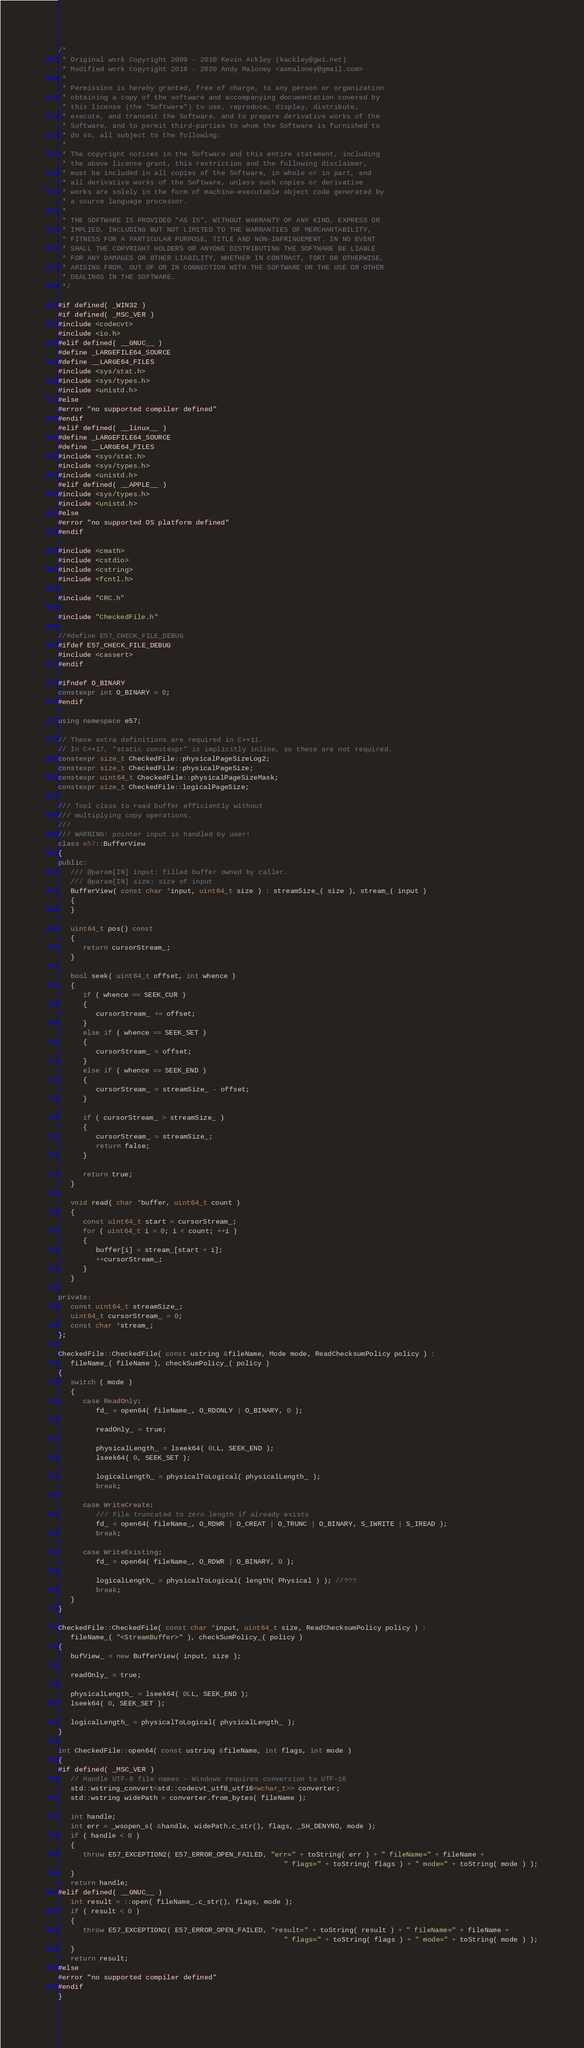Convert code to text. <code><loc_0><loc_0><loc_500><loc_500><_C++_>/*
 * Original work Copyright 2009 - 2010 Kevin Ackley (kackley@gwi.net)
 * Modified work Copyright 2018 - 2020 Andy Maloney <asmaloney@gmail.com>
 *
 * Permission is hereby granted, free of charge, to any person or organization
 * obtaining a copy of the software and accompanying documentation covered by
 * this license (the "Software") to use, reproduce, display, distribute,
 * execute, and transmit the Software, and to prepare derivative works of the
 * Software, and to permit third-parties to whom the Software is furnished to
 * do so, all subject to the following:
 *
 * The copyright notices in the Software and this entire statement, including
 * the above license grant, this restriction and the following disclaimer,
 * must be included in all copies of the Software, in whole or in part, and
 * all derivative works of the Software, unless such copies or derivative
 * works are solely in the form of machine-executable object code generated by
 * a source language processor.
 *
 * THE SOFTWARE IS PROVIDED "AS IS", WITHOUT WARRANTY OF ANY KIND, EXPRESS OR
 * IMPLIED, INCLUDING BUT NOT LIMITED TO THE WARRANTIES OF MERCHANTABILITY,
 * FITNESS FOR A PARTICULAR PURPOSE, TITLE AND NON-INFRINGEMENT. IN NO EVENT
 * SHALL THE COPYRIGHT HOLDERS OR ANYONE DISTRIBUTING THE SOFTWARE BE LIABLE
 * FOR ANY DAMAGES OR OTHER LIABILITY, WHETHER IN CONTRACT, TORT OR OTHERWISE,
 * ARISING FROM, OUT OF OR IN CONNECTION WITH THE SOFTWARE OR THE USE OR OTHER
 * DEALINGS IN THE SOFTWARE.
 */

#if defined( _WIN32 )
#if defined( _MSC_VER )
#include <codecvt>
#include <io.h>
#elif defined( __GNUC__ )
#define _LARGEFILE64_SOURCE
#define __LARGE64_FILES
#include <sys/stat.h>
#include <sys/types.h>
#include <unistd.h>
#else
#error "no supported compiler defined"
#endif
#elif defined( __linux__ )
#define _LARGEFILE64_SOURCE
#define __LARGE64_FILES
#include <sys/stat.h>
#include <sys/types.h>
#include <unistd.h>
#elif defined( __APPLE__ )
#include <sys/types.h>
#include <unistd.h>
#else
#error "no supported OS platform defined"
#endif

#include <cmath>
#include <cstdio>
#include <cstring>
#include <fcntl.h>

#include "CRC.h"

#include "CheckedFile.h"

//#define E57_CHECK_FILE_DEBUG
#ifdef E57_CHECK_FILE_DEBUG
#include <cassert>
#endif

#ifndef O_BINARY
constexpr int O_BINARY = 0;
#endif

using namespace e57;

// These extra definitions are required in C++11.
// In C++17, "static constexpr" is implicitly inline, so these are not required.
constexpr size_t CheckedFile::physicalPageSizeLog2;
constexpr size_t CheckedFile::physicalPageSize;
constexpr uint64_t CheckedFile::physicalPageSizeMask;
constexpr size_t CheckedFile::logicalPageSize;

/// Tool class to read buffer efficiently without
/// multiplying copy operations.
///
/// WARNING: pointer input is handled by user!
class e57::BufferView
{
public:
   /// @param[IN] input: filled buffer owned by caller.
   /// @param[IN] size: size of input
   BufferView( const char *input, uint64_t size ) : streamSize_( size ), stream_( input )
   {
   }

   uint64_t pos() const
   {
      return cursorStream_;
   }

   bool seek( uint64_t offset, int whence )
   {
      if ( whence == SEEK_CUR )
      {
         cursorStream_ += offset;
      }
      else if ( whence == SEEK_SET )
      {
         cursorStream_ = offset;
      }
      else if ( whence == SEEK_END )
      {
         cursorStream_ = streamSize_ - offset;
      }

      if ( cursorStream_ > streamSize_ )
      {
         cursorStream_ = streamSize_;
         return false;
      }

      return true;
   }

   void read( char *buffer, uint64_t count )
   {
      const uint64_t start = cursorStream_;
      for ( uint64_t i = 0; i < count; ++i )
      {
         buffer[i] = stream_[start + i];
         ++cursorStream_;
      }
   }

private:
   const uint64_t streamSize_;
   uint64_t cursorStream_ = 0;
   const char *stream_;
};

CheckedFile::CheckedFile( const ustring &fileName, Mode mode, ReadChecksumPolicy policy ) :
   fileName_( fileName ), checkSumPolicy_( policy )
{
   switch ( mode )
   {
      case ReadOnly:
         fd_ = open64( fileName_, O_RDONLY | O_BINARY, 0 );

         readOnly_ = true;

         physicalLength_ = lseek64( 0LL, SEEK_END );
         lseek64( 0, SEEK_SET );

         logicalLength_ = physicalToLogical( physicalLength_ );
         break;

      case WriteCreate:
         /// File truncated to zero length if already exists
         fd_ = open64( fileName_, O_RDWR | O_CREAT | O_TRUNC | O_BINARY, S_IWRITE | S_IREAD );
         break;

      case WriteExisting:
         fd_ = open64( fileName_, O_RDWR | O_BINARY, 0 );

         logicalLength_ = physicalToLogical( length( Physical ) ); //???
         break;
   }
}

CheckedFile::CheckedFile( const char *input, uint64_t size, ReadChecksumPolicy policy ) :
   fileName_( "<StreamBuffer>" ), checkSumPolicy_( policy )
{
   bufView_ = new BufferView( input, size );

   readOnly_ = true;

   physicalLength_ = lseek64( 0LL, SEEK_END );
   lseek64( 0, SEEK_SET );

   logicalLength_ = physicalToLogical( physicalLength_ );
}

int CheckedFile::open64( const ustring &fileName, int flags, int mode )
{
#if defined( _MSC_VER )
   // Handle UTF-8 file names - Windows requires conversion to UTF-16
   std::wstring_convert<std::codecvt_utf8_utf16<wchar_t>> converter;
   std::wstring widePath = converter.from_bytes( fileName );

   int handle;
   int err = _wsopen_s( &handle, widePath.c_str(), flags, _SH_DENYNO, mode );
   if ( handle < 0 )
   {
      throw E57_EXCEPTION2( E57_ERROR_OPEN_FAILED, "err=" + toString( err ) + " fileName=" + fileName +
                                                      " flags=" + toString( flags ) + " mode=" + toString( mode ) );
   }
   return handle;
#elif defined( __GNUC__ )
   int result = ::open( fileName_.c_str(), flags, mode );
   if ( result < 0 )
   {
      throw E57_EXCEPTION2( E57_ERROR_OPEN_FAILED, "result=" + toString( result ) + " fileName=" + fileName +
                                                      " flags=" + toString( flags ) + " mode=" + toString( mode ) );
   }
   return result;
#else
#error "no supported compiler defined"
#endif
}
</code> 